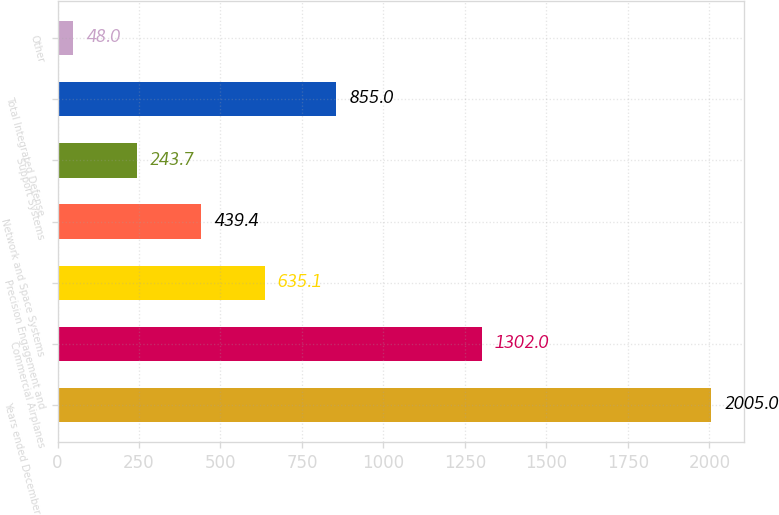<chart> <loc_0><loc_0><loc_500><loc_500><bar_chart><fcel>Years ended December 31<fcel>Commercial Airplanes<fcel>Precision Engagement and<fcel>Network and Space Systems<fcel>Support Systems<fcel>Total Integrated Defense<fcel>Other<nl><fcel>2005<fcel>1302<fcel>635.1<fcel>439.4<fcel>243.7<fcel>855<fcel>48<nl></chart> 